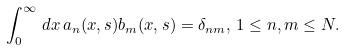Convert formula to latex. <formula><loc_0><loc_0><loc_500><loc_500>\int _ { 0 } ^ { \infty } \, d x \, a _ { n } ( x , s ) b _ { m } ( x , s ) = \delta _ { n m } , \, 1 \leq n , m \leq N .</formula> 